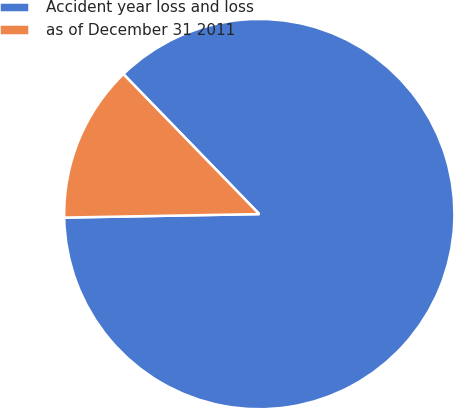Convert chart to OTSL. <chart><loc_0><loc_0><loc_500><loc_500><pie_chart><fcel>Accident year loss and loss<fcel>as of December 31 2011<nl><fcel>86.98%<fcel>13.02%<nl></chart> 